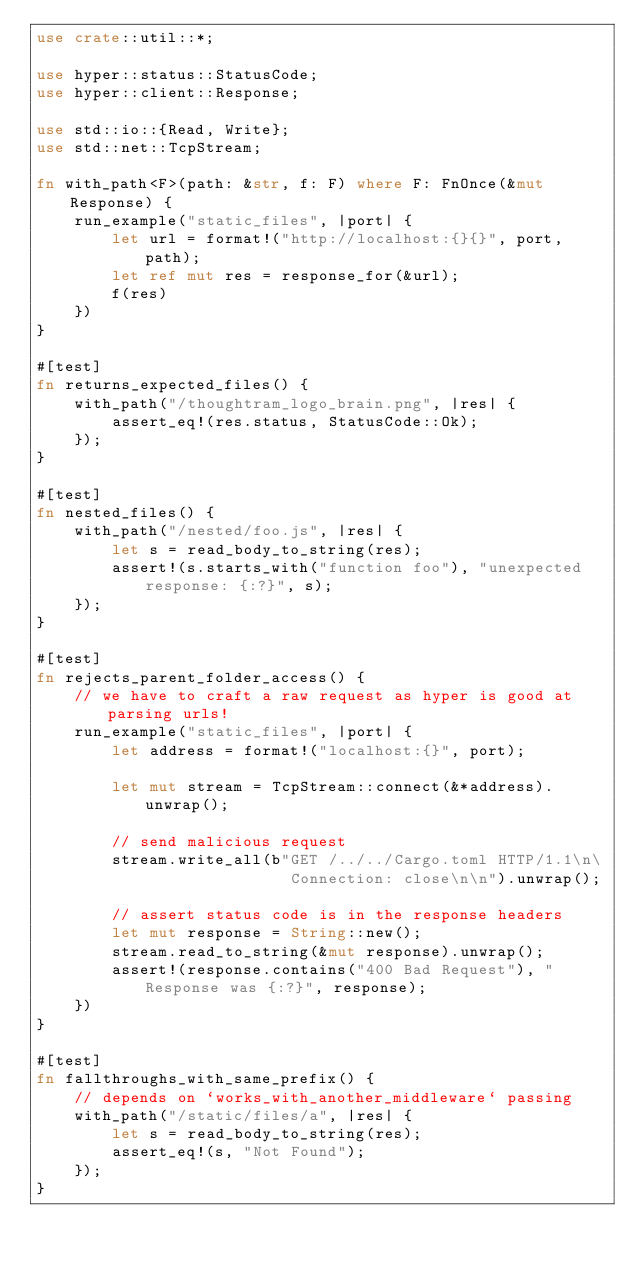<code> <loc_0><loc_0><loc_500><loc_500><_Rust_>use crate::util::*;

use hyper::status::StatusCode;
use hyper::client::Response;

use std::io::{Read, Write};
use std::net::TcpStream;

fn with_path<F>(path: &str, f: F) where F: FnOnce(&mut Response) {
    run_example("static_files", |port| {
        let url = format!("http://localhost:{}{}", port, path);
        let ref mut res = response_for(&url);
        f(res)
    })
}

#[test]
fn returns_expected_files() {
    with_path("/thoughtram_logo_brain.png", |res| {
        assert_eq!(res.status, StatusCode::Ok);
    });
}

#[test]
fn nested_files() {
    with_path("/nested/foo.js", |res| {
        let s = read_body_to_string(res);
        assert!(s.starts_with("function foo"), "unexpected response: {:?}", s);
    });
}

#[test]
fn rejects_parent_folder_access() {
    // we have to craft a raw request as hyper is good at parsing urls!
    run_example("static_files", |port| {
        let address = format!("localhost:{}", port);

        let mut stream = TcpStream::connect(&*address).unwrap();

        // send malicious request
        stream.write_all(b"GET /../../Cargo.toml HTTP/1.1\n\
                           Connection: close\n\n").unwrap();

        // assert status code is in the response headers
        let mut response = String::new();
        stream.read_to_string(&mut response).unwrap();
        assert!(response.contains("400 Bad Request"), "Response was {:?}", response);
    })
}

#[test]
fn fallthroughs_with_same_prefix() {
    // depends on `works_with_another_middleware` passing
    with_path("/static/files/a", |res| {
        let s = read_body_to_string(res);
        assert_eq!(s, "Not Found");
    });
}
</code> 